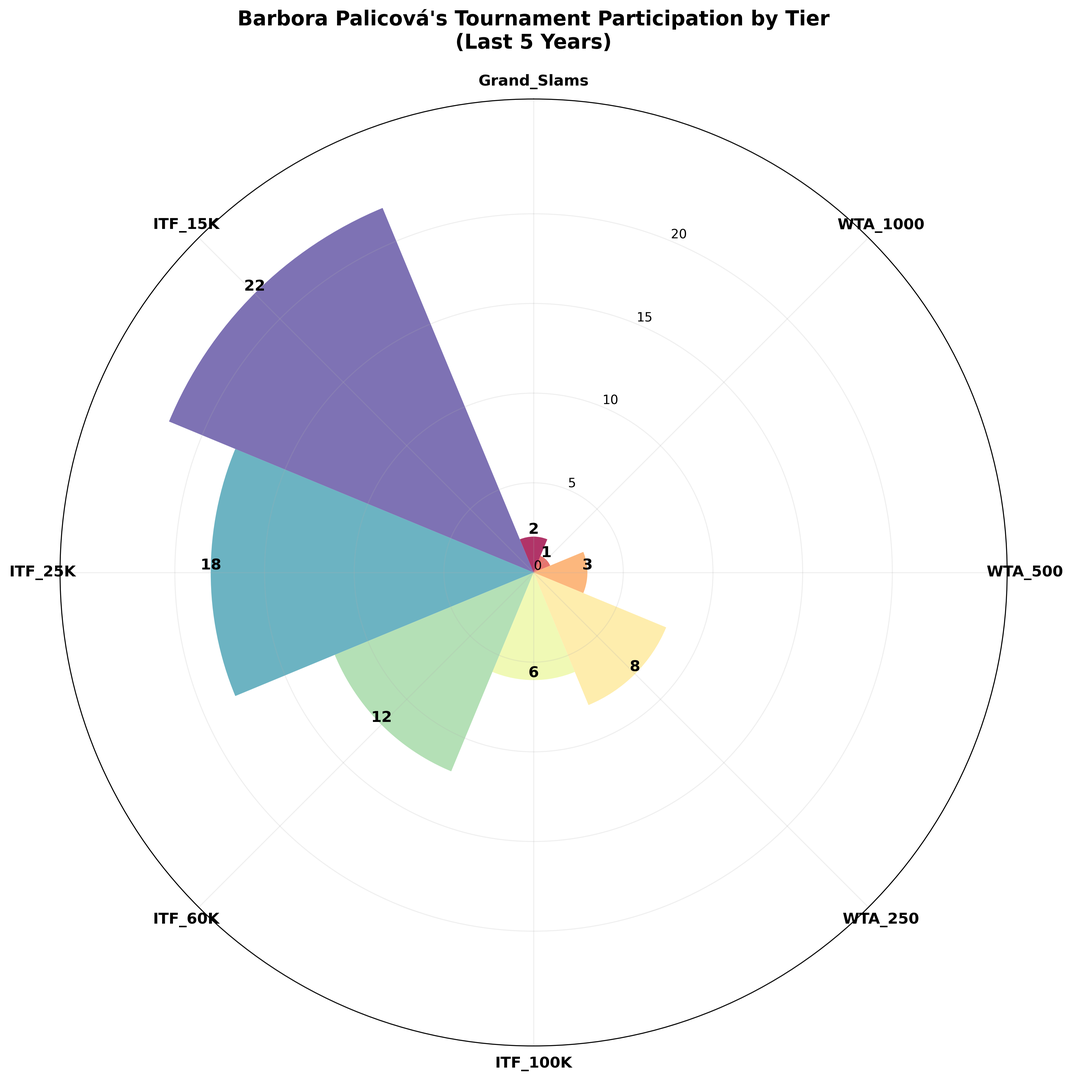What tournament tier has the highest participation count? Identify the bar with the highest height. The highest bar corresponds to the ITF 15K tier.
Answer: ITF 15K Which tournament tier has the lowest participation count? Identify the bar with the lowest height. The lowest bar corresponds to the WTA 1000 tier.
Answer: WTA 1000 How many Grand Slam tournaments has Barbora Palicová participated in over the last 5 years? Locate the bar labeled 'Grand Slams' and read its height, which represents the participation count.
Answer: 2 What is the sum of participation counts for all ITF tournaments? Sum the heights of the bars labeled ITF 100K, ITF 60K, ITF 25K, and ITF 15K. The values are 6, 12, 18, and 22 respectively, so the sum is 6 + 12 + 18 + 22 = 58.
Answer: 58 What is the difference in participation counts between the ITF 15K and ITF 100K tiers? Subtract the height of the ITF 100K bar from the height of the ITF 15K bar. The values are 22 and 6 respectively, so the difference is 22 - 6 = 16.
Answer: 16 How does Barbora Palicová's participation in WTA 250 tournaments compare to WTA 500 tournaments? Compare the heights of the bars labeled WTA 250 and WTA 500. The WTA 250 bar is higher, indicating more participations in WTA 250 tournaments (8 vs 3).
Answer: More in WTA 250 How many more ITF 60K tournaments has Barbora Palicová participated in compared to WTA 1000 tournaments? Subtract the height of the WTA 1000 bar from the height of the ITF 60K bar. The values are 12 and 1 respectively, so the difference is 12 - 1 = 11.
Answer: 11 What is the average participation count for all tournaments? Calculate the average by summing all participation counts and dividing by the number of tiers. The values are 2, 1, 3, 8, 6, 12, 18, and 22. The sum is 2 + 1 + 3 + 8 + 6 + 12 + 18 + 22 = 72. The number of tiers is 8, so the average is 72 / 8 = 9.
Answer: 9 